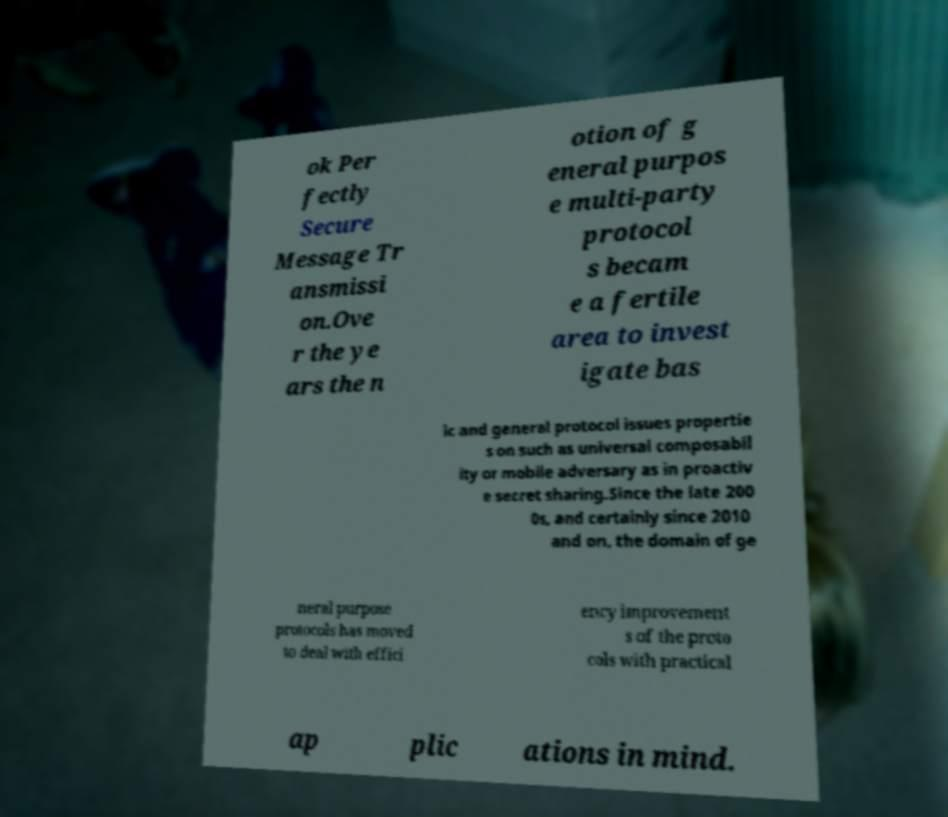There's text embedded in this image that I need extracted. Can you transcribe it verbatim? ok Per fectly Secure Message Tr ansmissi on.Ove r the ye ars the n otion of g eneral purpos e multi-party protocol s becam e a fertile area to invest igate bas ic and general protocol issues propertie s on such as universal composabil ity or mobile adversary as in proactiv e secret sharing.Since the late 200 0s, and certainly since 2010 and on, the domain of ge neral purpose protocols has moved to deal with effici ency improvement s of the proto cols with practical ap plic ations in mind. 